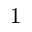Convert formula to latex. <formula><loc_0><loc_0><loc_500><loc_500>^ { 1 }</formula> 